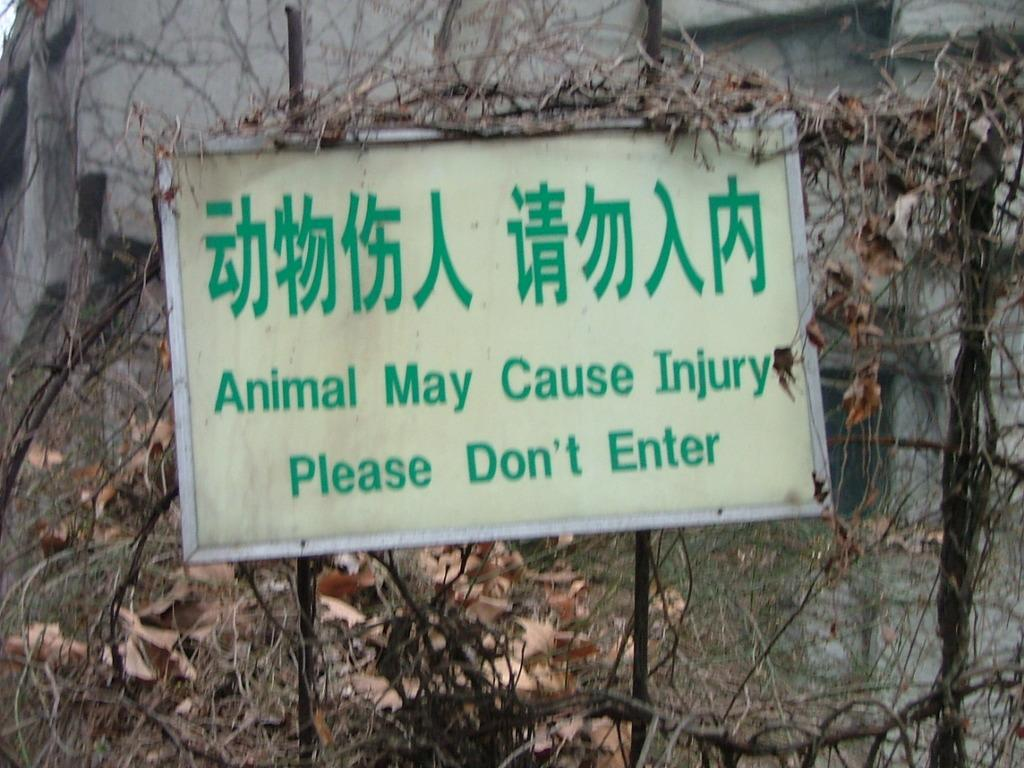What is written on the board in the image? The board has green text in the image. What can be seen in the background of the image? There is a wire fence, dry leaves, and a building in the background of the image. What type of nose can be seen on the cloud in the image? There is no cloud or nose present in the image. How does the neck of the building appear in the image? There is no neck present in the image, as buildings do not have necks. 